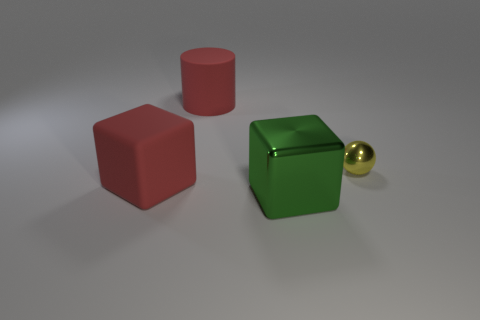Add 2 small blocks. How many objects exist? 6 Subtract all cylinders. How many objects are left? 3 Add 2 big matte cylinders. How many big matte cylinders exist? 3 Subtract 1 yellow spheres. How many objects are left? 3 Subtract all big yellow rubber things. Subtract all matte cubes. How many objects are left? 3 Add 1 cylinders. How many cylinders are left? 2 